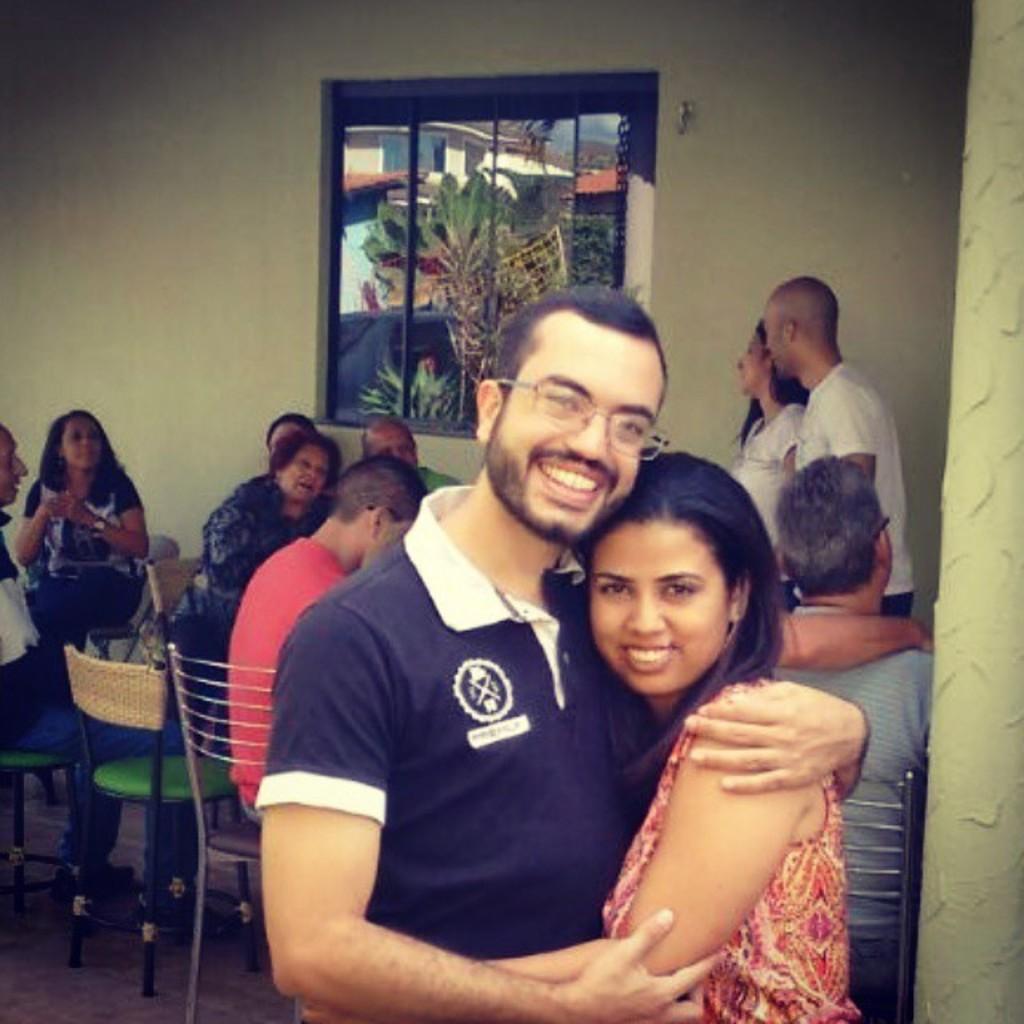Could you give a brief overview of what you see in this image? In the center of the image we can see a man and a lady standing and smiling. In the background there are people sitting. There are chairs and we can see a window and a wall. 